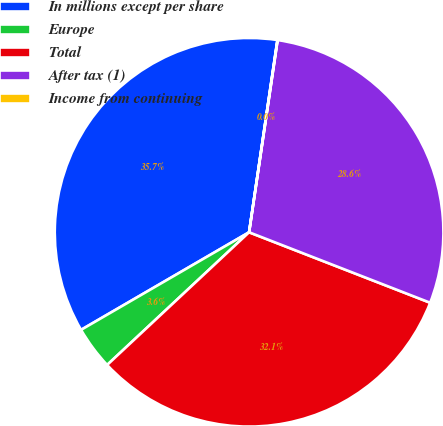Convert chart. <chart><loc_0><loc_0><loc_500><loc_500><pie_chart><fcel>In millions except per share<fcel>Europe<fcel>Total<fcel>After tax (1)<fcel>Income from continuing<nl><fcel>35.7%<fcel>3.59%<fcel>32.13%<fcel>28.56%<fcel>0.02%<nl></chart> 